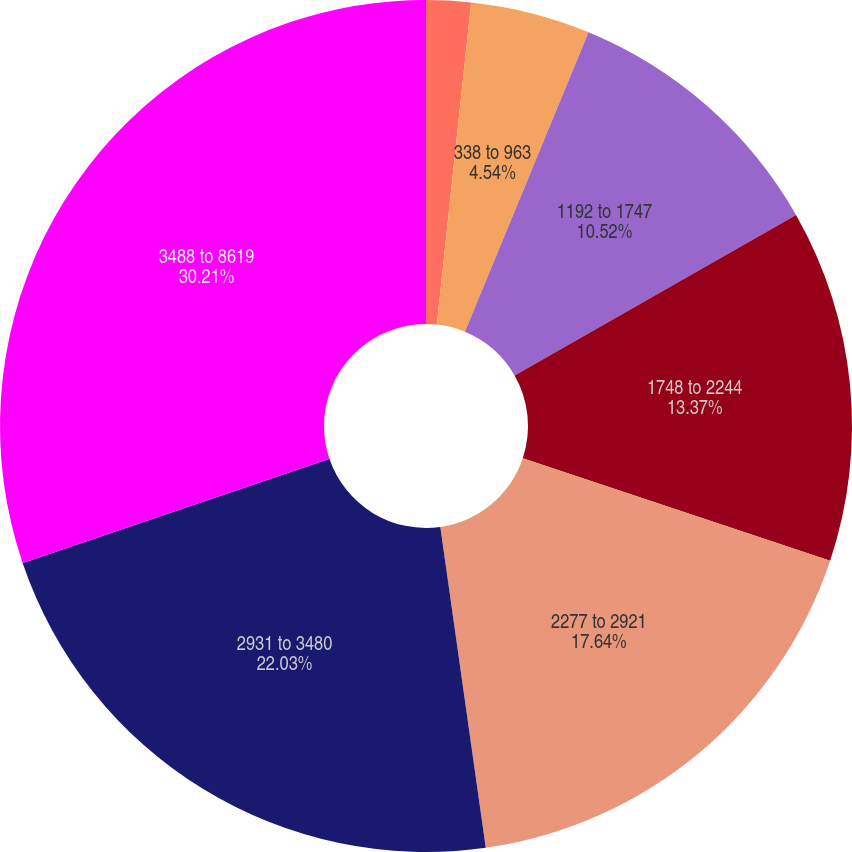Convert chart. <chart><loc_0><loc_0><loc_500><loc_500><pie_chart><fcel>007 to 337<fcel>338 to 963<fcel>1192 to 1747<fcel>1748 to 2244<fcel>2277 to 2921<fcel>2931 to 3480<fcel>3488 to 8619<nl><fcel>1.69%<fcel>4.54%<fcel>10.52%<fcel>13.37%<fcel>17.64%<fcel>22.03%<fcel>30.21%<nl></chart> 